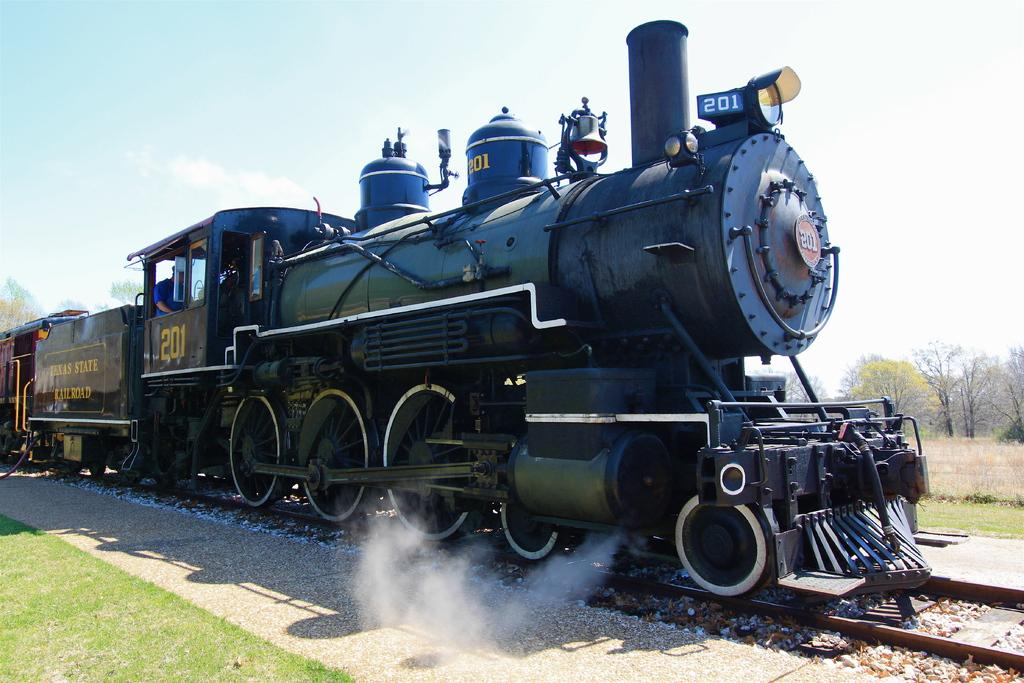What is the main subject of the image? The main subject of the image is a train. What is the train situated on? The train is situated on a railway track. What type of vegetation can be seen in the image? There is grass and trees visible in the image. What is visible at the top of the image? The sky is visible at the top of the image. What type of chalk is being used to draw on the train in the image? There is no chalk or drawing present on the train in the image. What kind of lunch is being served to the passengers on the train in the image? There is no indication of passengers or lunch being served on the train in the image. 